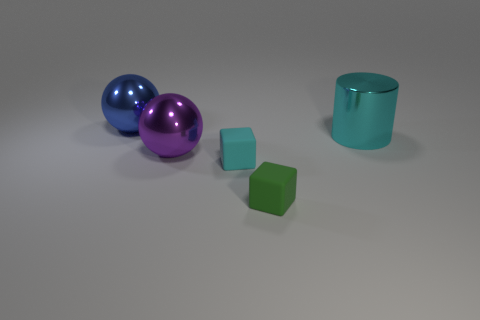How many objects are right of the big purple thing and behind the tiny green rubber block?
Ensure brevity in your answer.  2. Is the large cylinder made of the same material as the green object?
Ensure brevity in your answer.  No. There is a big thing right of the cyan thing in front of the big metallic ball to the right of the blue metal thing; what is its shape?
Offer a very short reply. Cylinder. There is a thing that is both behind the cyan block and in front of the big metallic cylinder; what material is it made of?
Your answer should be very brief. Metal. What color is the large metallic thing in front of the cyan object that is right of the tiny matte cube behind the small green thing?
Offer a terse response. Purple. Do the blue thing on the left side of the small green cube and the big ball in front of the large blue object have the same material?
Your response must be concise. Yes. How many spheres have the same material as the purple thing?
Provide a succinct answer. 1. Is the shape of the matte thing behind the tiny green object the same as the green object on the left side of the big cyan cylinder?
Keep it short and to the point. Yes. What color is the metallic object that is both behind the purple metal sphere and on the right side of the blue sphere?
Offer a terse response. Cyan. Is the size of the rubber block on the right side of the tiny cyan matte object the same as the cyan thing that is behind the cyan matte cube?
Your answer should be compact. No. 